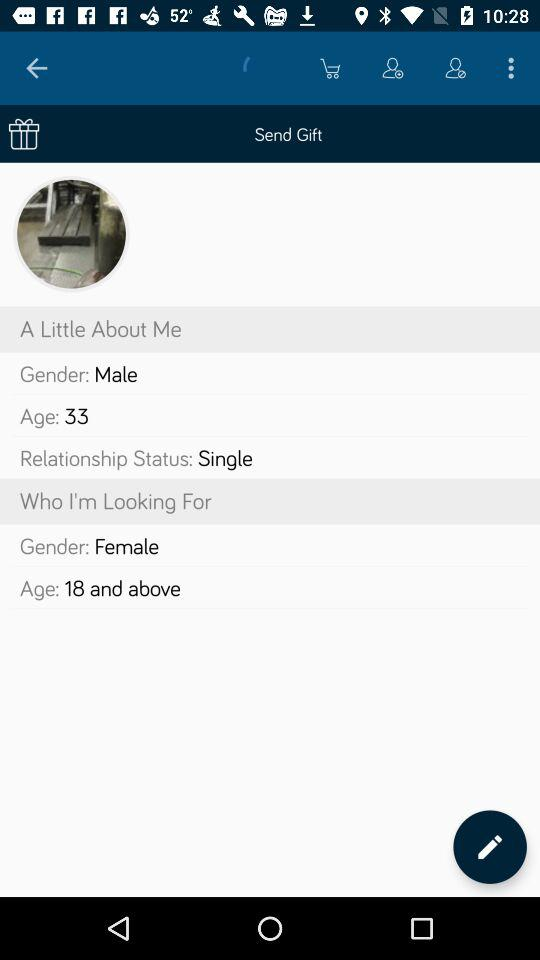What is the status of the relationship? The status is "Single". 